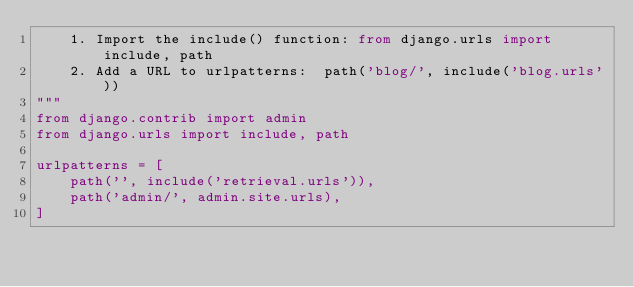<code> <loc_0><loc_0><loc_500><loc_500><_Python_>    1. Import the include() function: from django.urls import include, path
    2. Add a URL to urlpatterns:  path('blog/', include('blog.urls'))
"""
from django.contrib import admin
from django.urls import include, path

urlpatterns = [
    path('', include('retrieval.urls')),
    path('admin/', admin.site.urls),
]</code> 